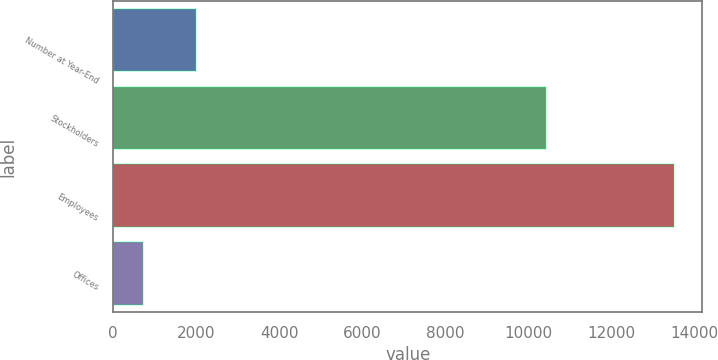Convert chart. <chart><loc_0><loc_0><loc_500><loc_500><bar_chart><fcel>Number at Year-End<fcel>Stockholders<fcel>Employees<fcel>Offices<nl><fcel>2005<fcel>10437<fcel>13525<fcel>724<nl></chart> 